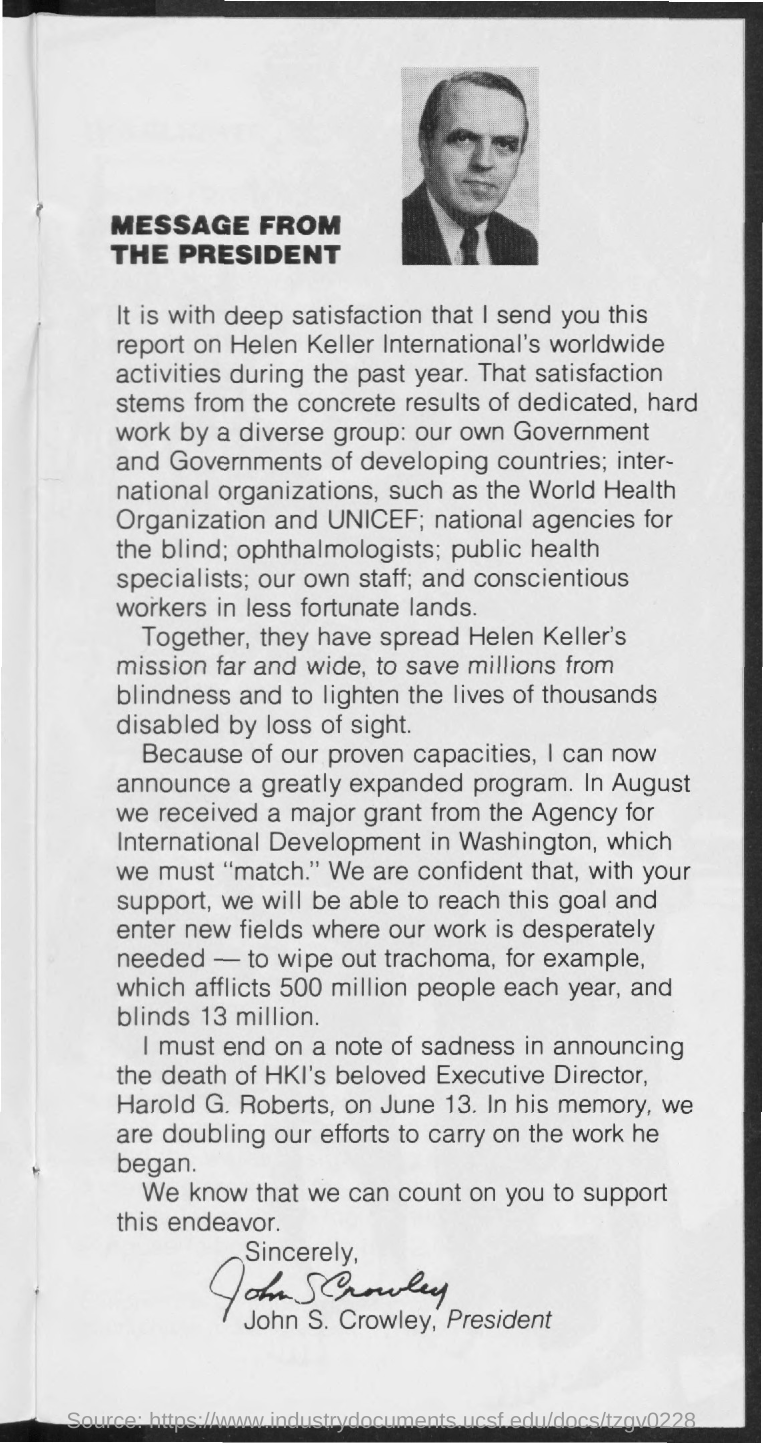Identify some key points in this picture. The main heading of the document is 'What is the main heading of the document? message from the president.' 